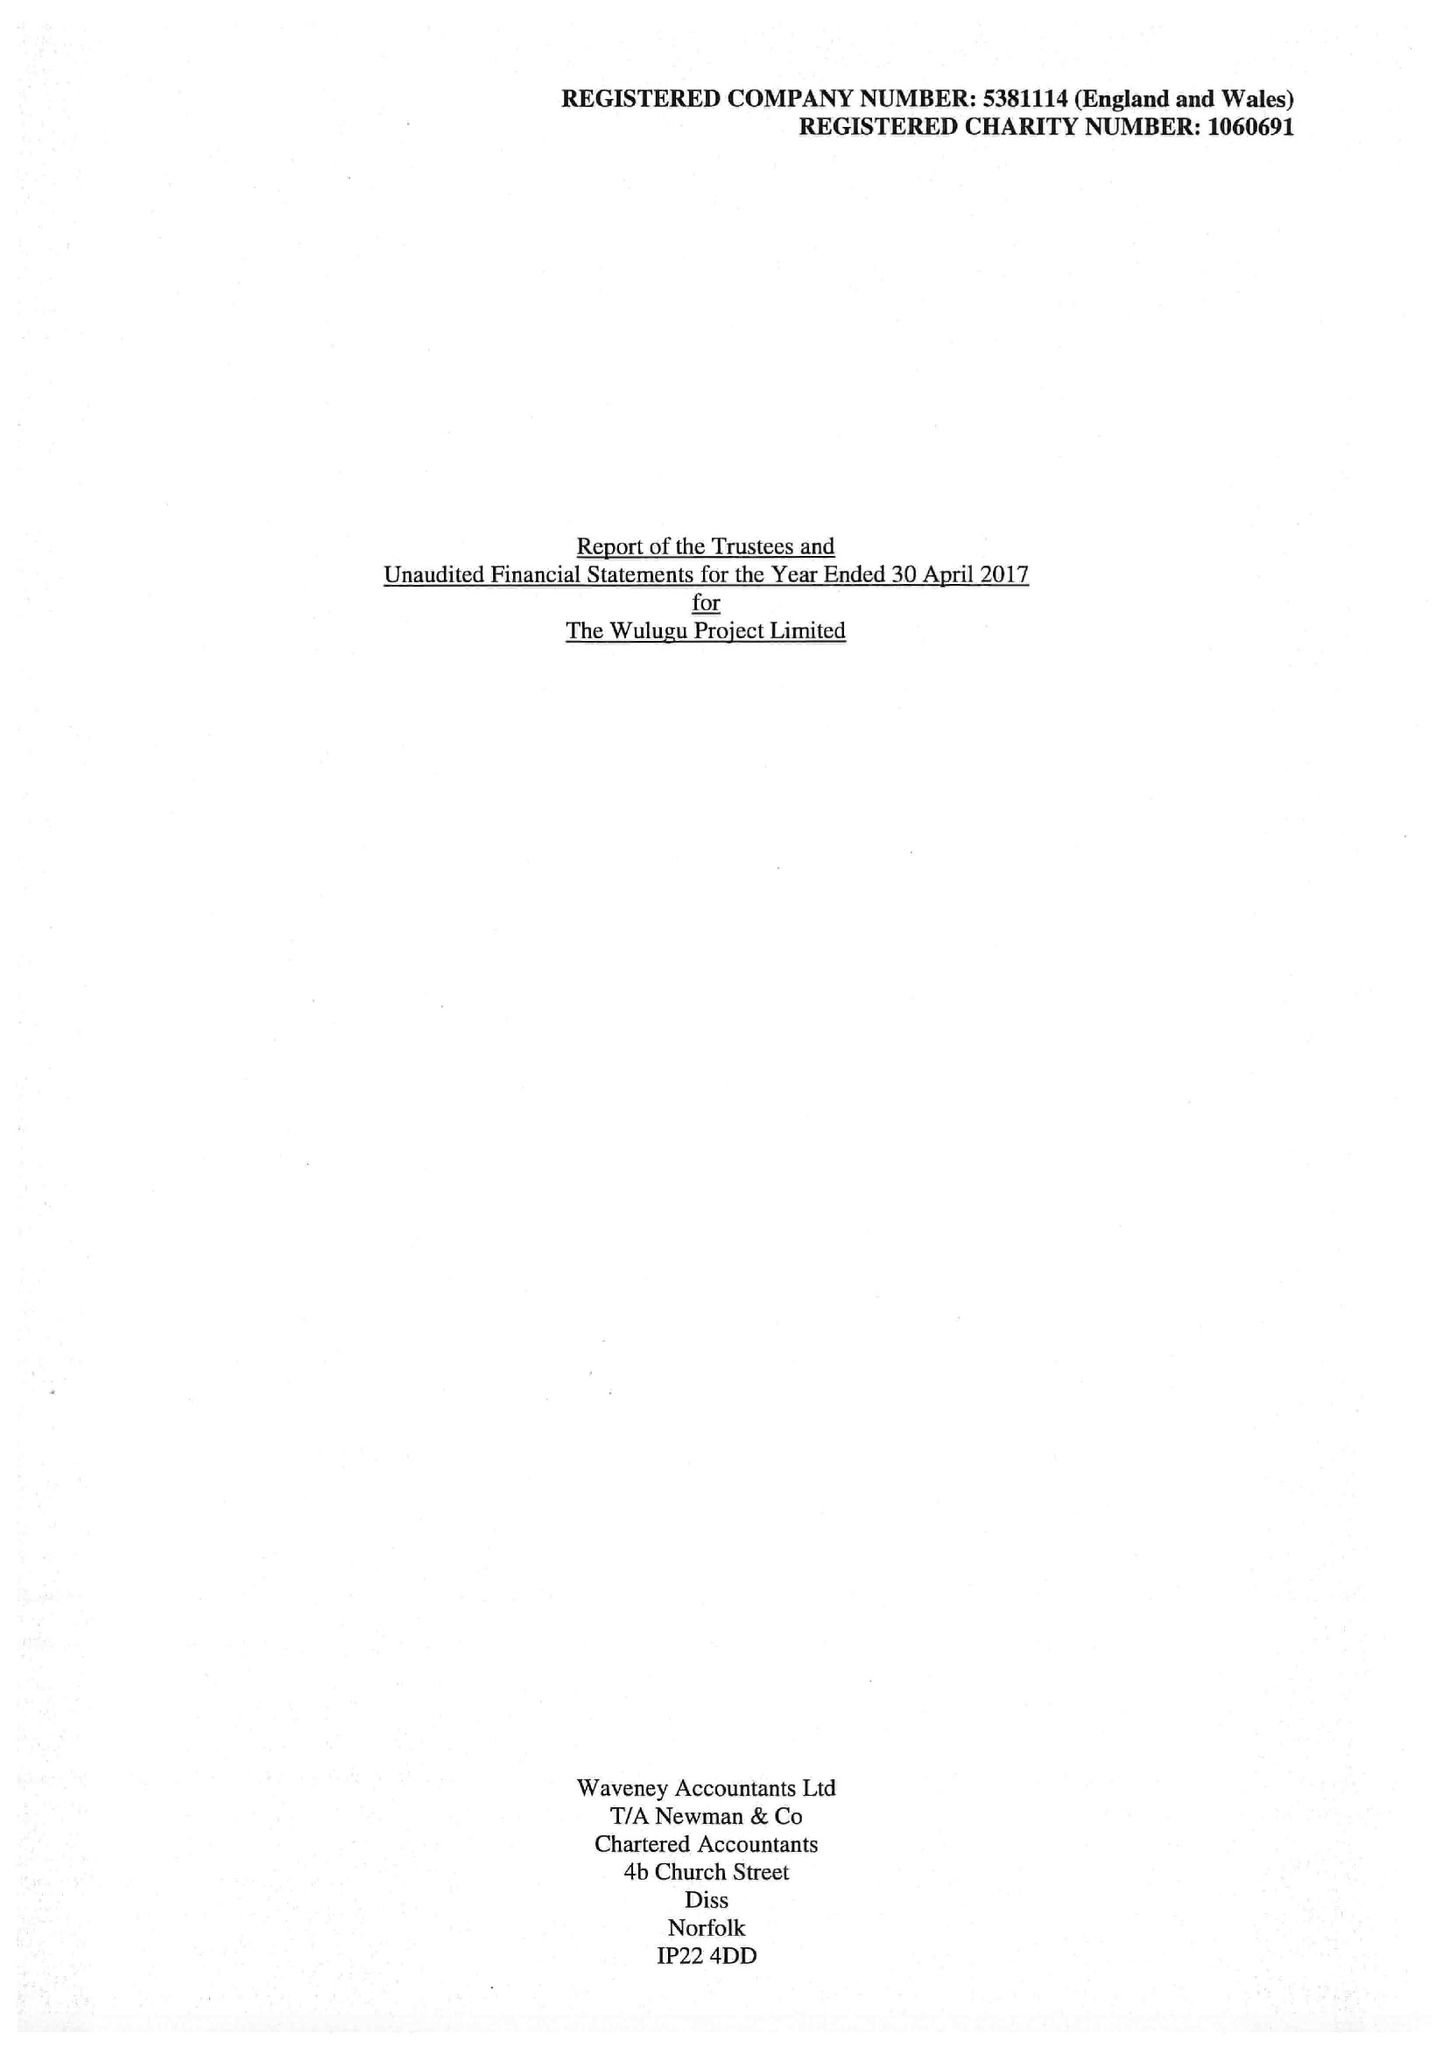What is the value for the address__post_town?
Answer the question using a single word or phrase. NORWICH 